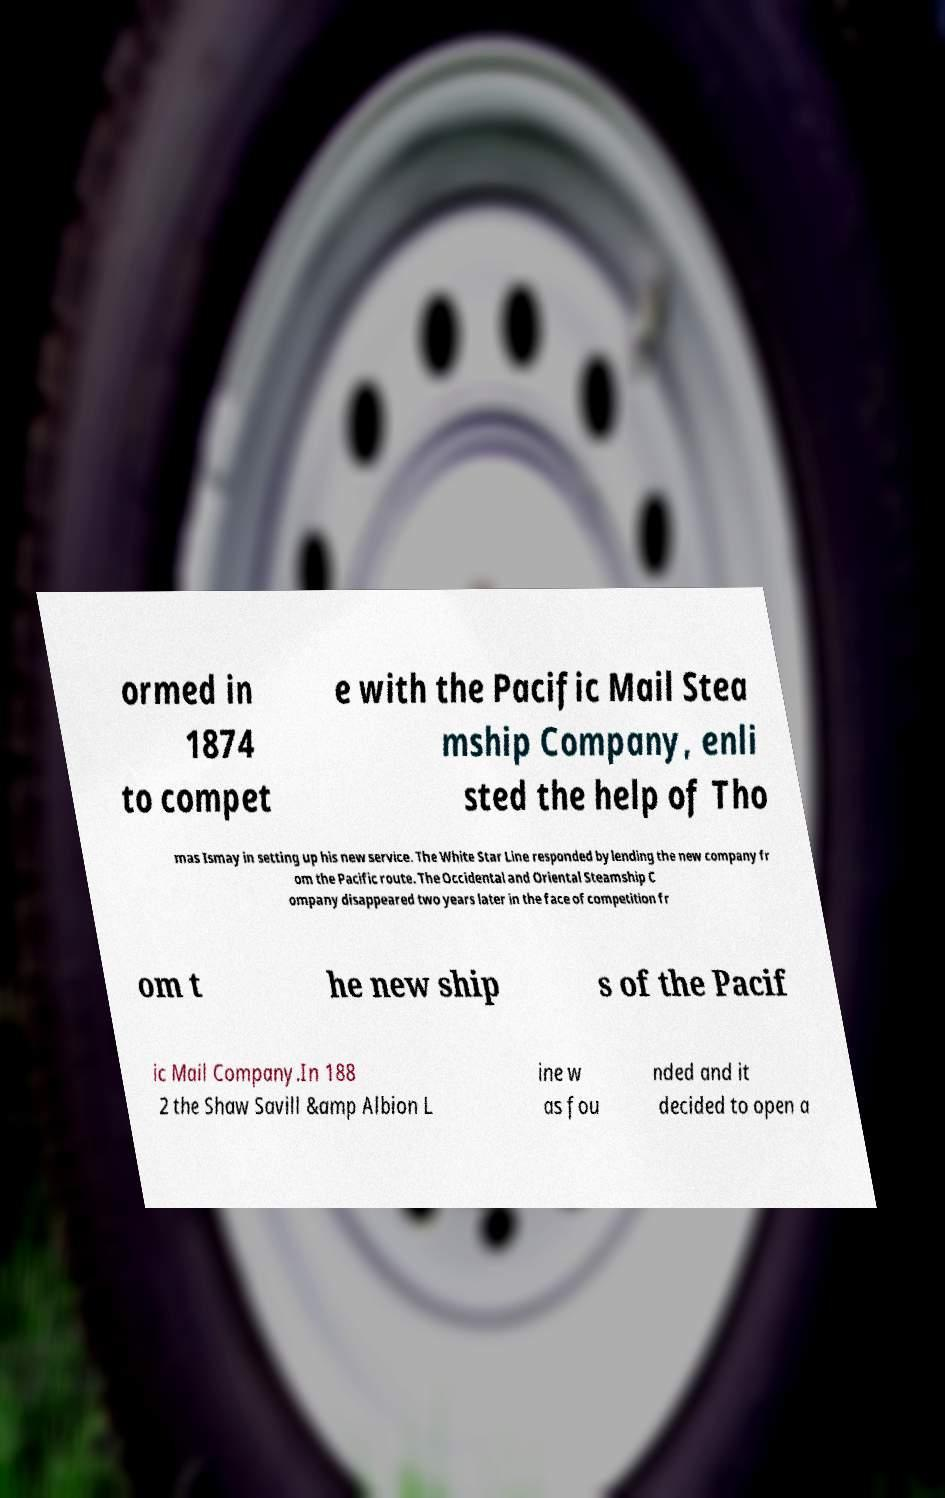Please read and relay the text visible in this image. What does it say? ormed in 1874 to compet e with the Pacific Mail Stea mship Company, enli sted the help of Tho mas Ismay in setting up his new service. The White Star Line responded by lending the new company fr om the Pacific route. The Occidental and Oriental Steamship C ompany disappeared two years later in the face of competition fr om t he new ship s of the Pacif ic Mail Company.In 188 2 the Shaw Savill &amp Albion L ine w as fou nded and it decided to open a 